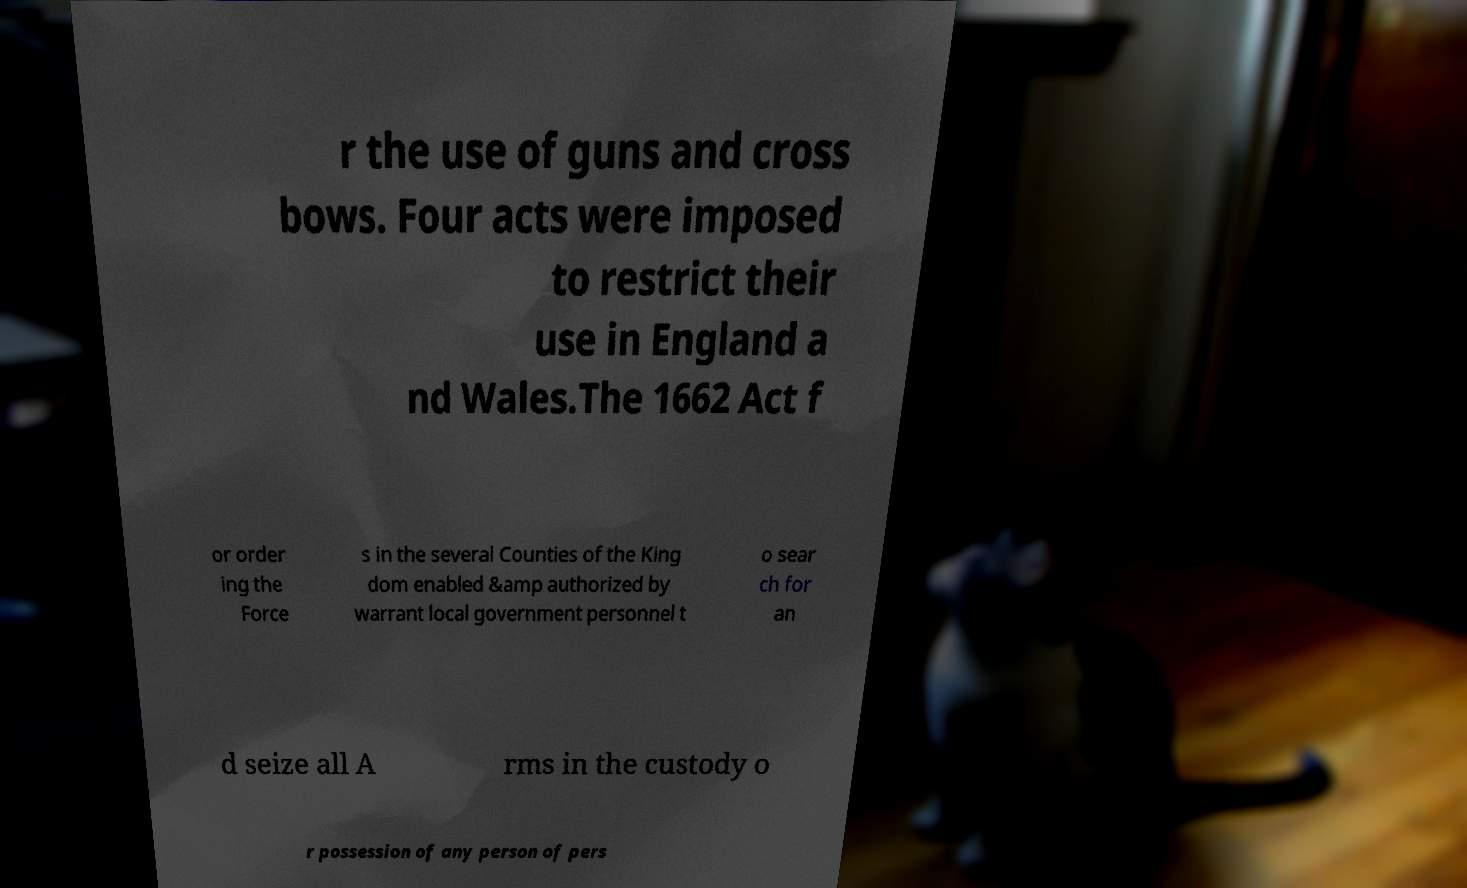Can you read and provide the text displayed in the image?This photo seems to have some interesting text. Can you extract and type it out for me? r the use of guns and cross bows. Four acts were imposed to restrict their use in England a nd Wales.The 1662 Act f or order ing the Force s in the several Counties of the King dom enabled &amp authorized by warrant local government personnel t o sear ch for an d seize all A rms in the custody o r possession of any person of pers 